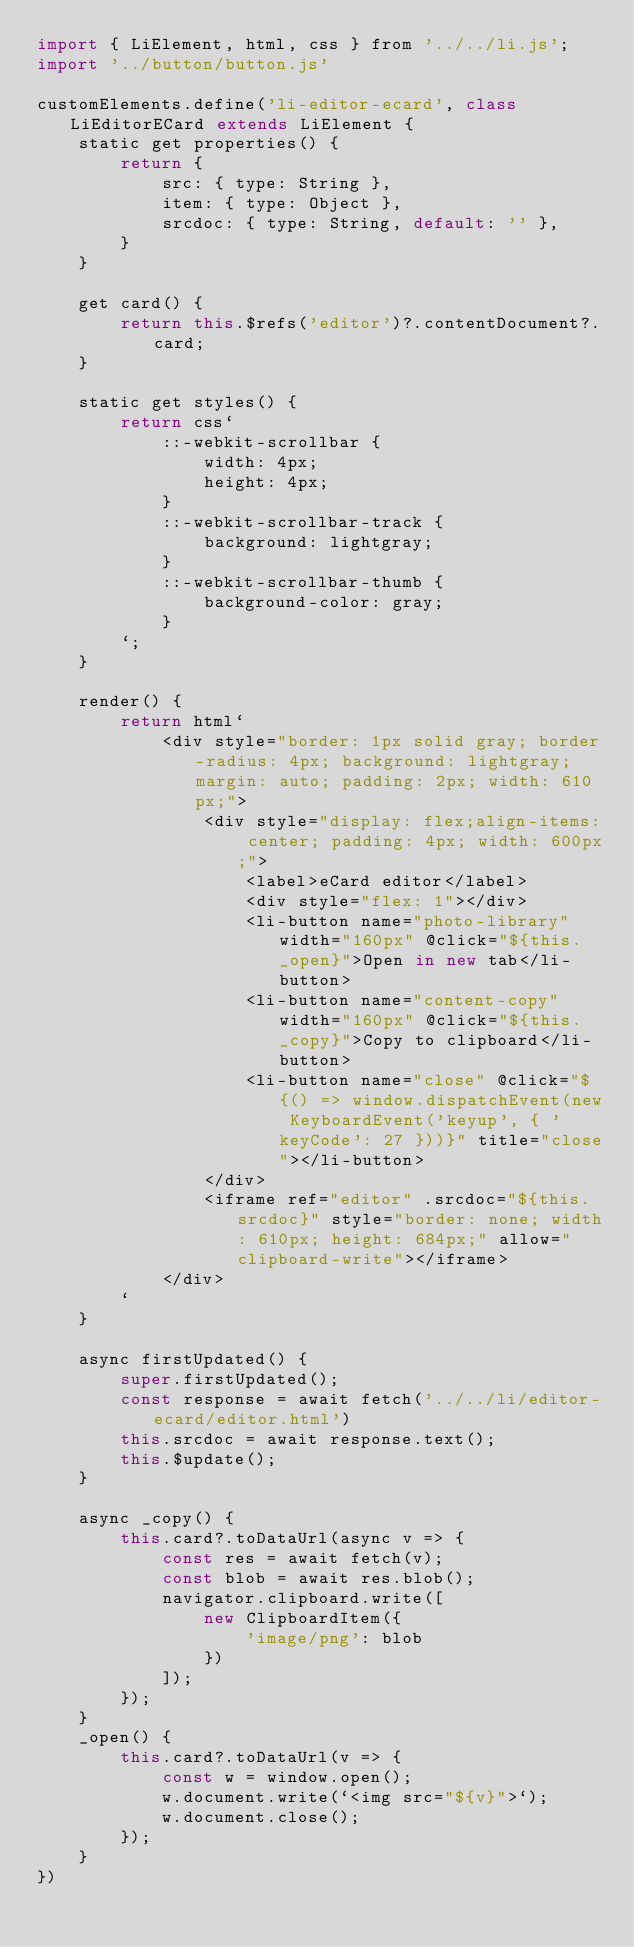<code> <loc_0><loc_0><loc_500><loc_500><_JavaScript_>import { LiElement, html, css } from '../../li.js';
import '../button/button.js'

customElements.define('li-editor-ecard', class LiEditorECard extends LiElement {
    static get properties() {
        return {
            src: { type: String },
            item: { type: Object },
            srcdoc: { type: String, default: '' },
        }
    }

    get card() {
        return this.$refs('editor')?.contentDocument?.card;
    }

    static get styles() {
        return css`
            ::-webkit-scrollbar {
                width: 4px;
                height: 4px;
            }
            ::-webkit-scrollbar-track {
                background: lightgray;
            }
            ::-webkit-scrollbar-thumb {
                background-color: gray;
            }
        `;
    }

    render() {
        return html`
            <div style="border: 1px solid gray; border-radius: 4px; background: lightgray; margin: auto; padding: 2px; width: 610px;">
                <div style="display: flex;align-items: center; padding: 4px; width: 600px;">
                    <label>eCard editor</label>
                    <div style="flex: 1"></div>
                    <li-button name="photo-library" width="160px" @click="${this._open}">Open in new tab</li-button>
                    <li-button name="content-copy" width="160px" @click="${this._copy}">Copy to clipboard</li-button>
                    <li-button name="close" @click="${() => window.dispatchEvent(new KeyboardEvent('keyup', { 'keyCode': 27 }))}" title="close"></li-button>
                </div>
                <iframe ref="editor" .srcdoc="${this.srcdoc}" style="border: none; width: 610px; height: 684px;" allow="clipboard-write"></iframe>
            </div>
        `
    }

    async firstUpdated() {
        super.firstUpdated();
        const response = await fetch('../../li/editor-ecard/editor.html')
        this.srcdoc = await response.text();
        this.$update();
    }

    async _copy() {
        this.card?.toDataUrl(async v => {
            const res = await fetch(v);
            const blob = await res.blob();
            navigator.clipboard.write([
                new ClipboardItem({
                    'image/png': blob
                })
            ]);
        });
    }
    _open() {
        this.card?.toDataUrl(v => {
            const w = window.open();
            w.document.write(`<img src="${v}">`);
            w.document.close();
        });
    }
})
</code> 